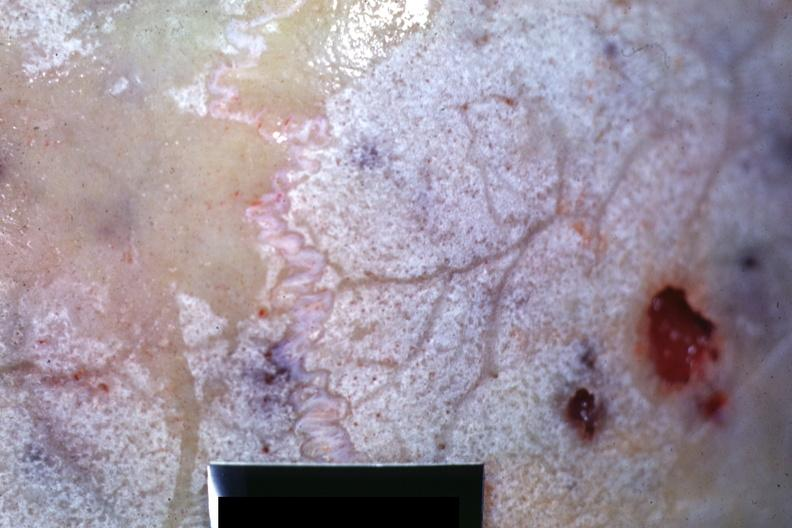s previous slide from this case present?
Answer the question using a single word or phrase. No 